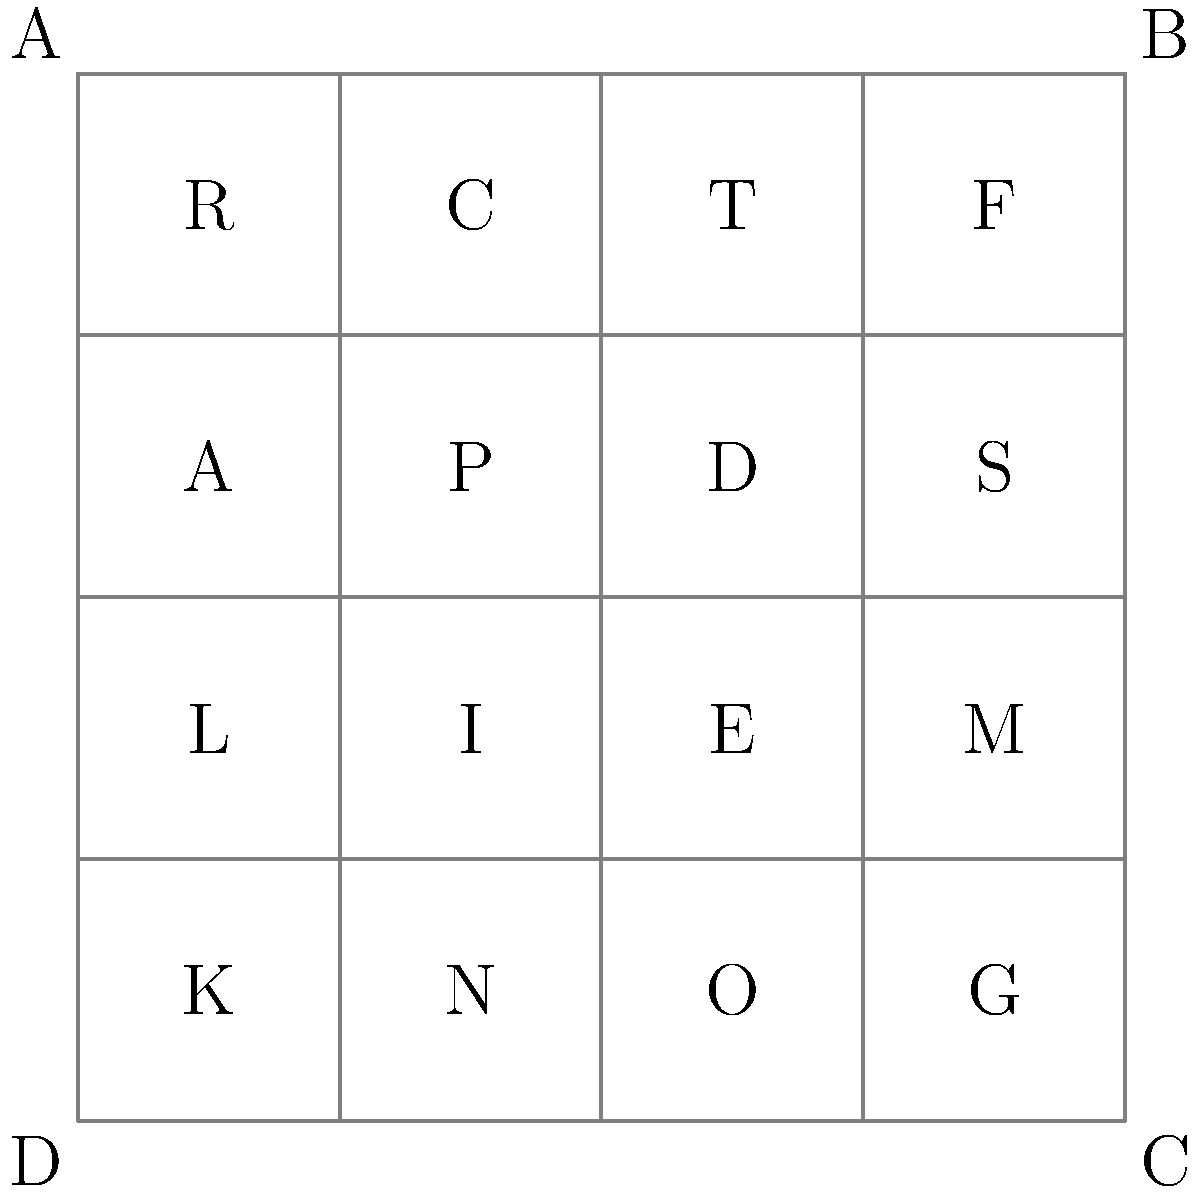A regulatory compliance checklist for online lending platforms is represented as a 4x4 grid, where each cell contains a letter representing a specific compliance item. The symmetry group of this grid includes rotations and reflections that preserve the structure of the checklist. How many unique arrangements of the checklist can be created using only the operations in the symmetry group of the square? To solve this problem, we need to understand the symmetry group of a square and how it applies to our regulatory compliance checklist grid. Let's break it down step-by-step:

1. The symmetry group of a square, known as D4 (Dihedral group of order 8), consists of 8 symmetry operations:
   - Identity (do nothing)
   - 3 rotations (90°, 180°, 270°)
   - 4 reflections (2 diagonal, 2 axial)

2. These 8 operations form the orbit of any arrangement of the checklist. This means that applying these operations to any given arrangement will produce at most 8 different arrangements.

3. The number of unique arrangements is determined by the orbit-stabilizer theorem:
   $$ \text{Number of unique arrangements} = \frac{\text{Total number of arrangements}}{\text{Size of the symmetry group}} $$

4. The total number of arrangements for a 4x4 grid with 16 distinct elements is 16! (16 factorial).

5. Applying the orbit-stabilizer theorem:
   $$ \text{Number of unique arrangements} = \frac{16!}{8} $$

6. Simplifying:
   $$ \text{Number of unique arrangements} = \frac{16!}{8} = 2,580,480,000 $$

This means that out of all possible arrangements of the 16 compliance items, there are 2,580,480,000 unique arrangements when considering the symmetry operations of the square grid.
Answer: 2,580,480,000 